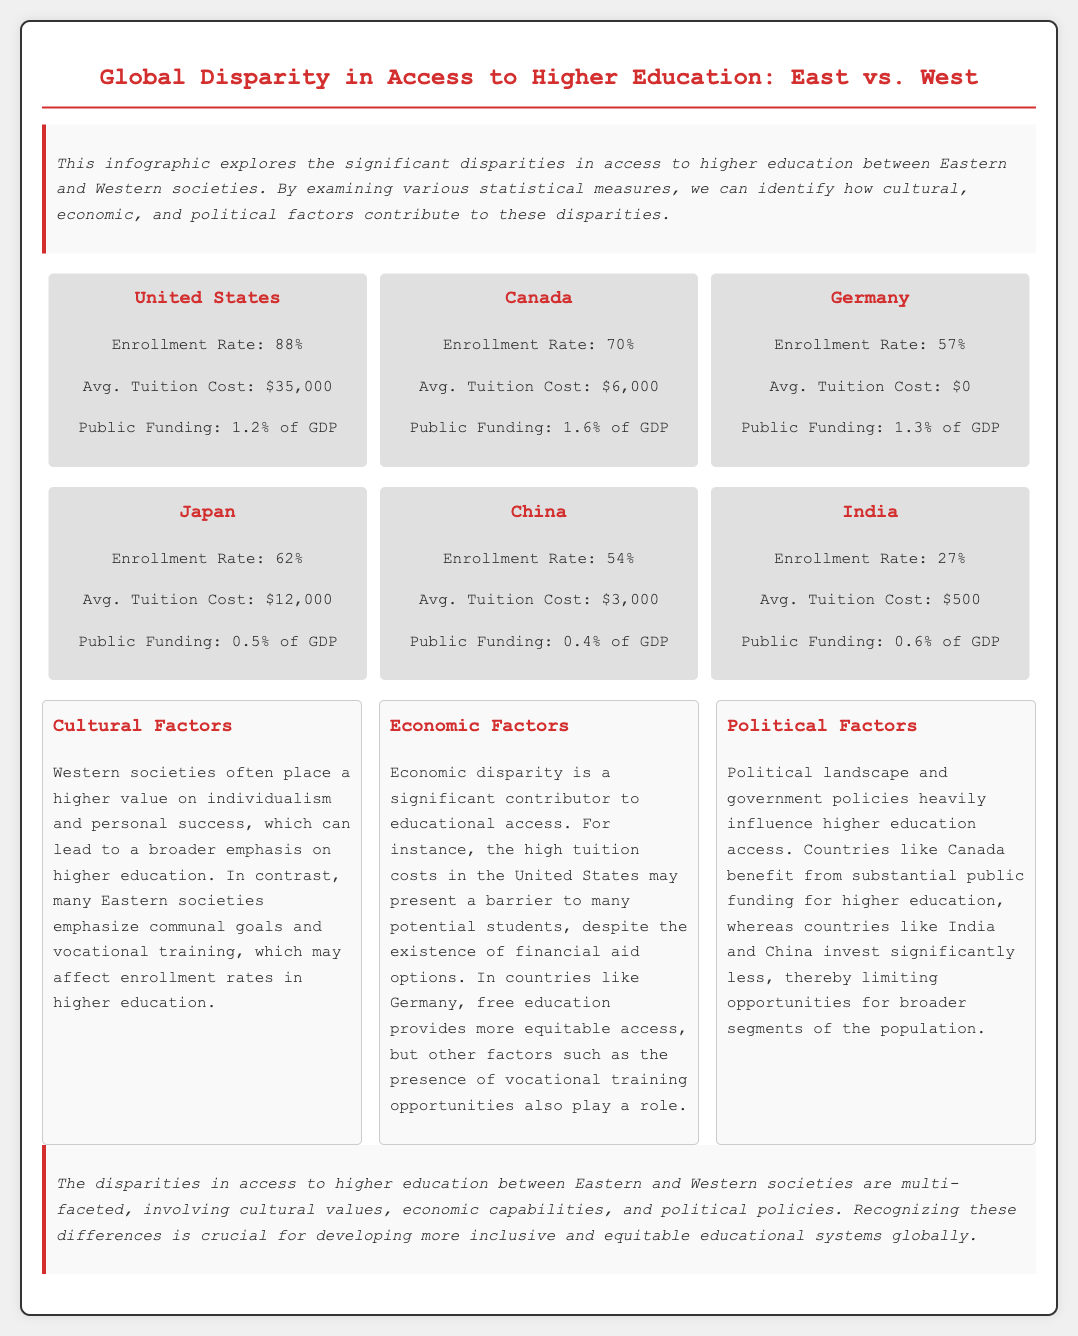What is the enrollment rate in the United States? The enrollment rate in the United States is provided in the stats section of the document.
Answer: 88% What is the average tuition cost in Germany? The average tuition cost for Germany is listed along with its enrollment rate in the document.
Answer: $0 Which country has the lowest enrollment rate? The document lists all countries and their enrollment rates, indicating which one is the lowest.
Answer: India What percentage of GDP does Canada allocate to public funding for higher education? The document provides the percentage of GDP allocated for public funding in Canada.
Answer: 1.6% How do cultural factors influence higher education access according to the document? The document explains how cultural values differ between Western and Eastern societies, influencing education emphasis.
Answer: Individualism Which country benefits from substantial public funding for higher education? The document specifically mentions Canada as benefiting from substantial public funding.
Answer: Canada What are the three main factors affecting higher education access? The document outlines various factors that contribute to disparities in higher education access.
Answer: Cultural, Economic, Political What is the average tuition cost in China? The average tuition cost in China is provided in the statistical data of the document.
Answer: $3,000 